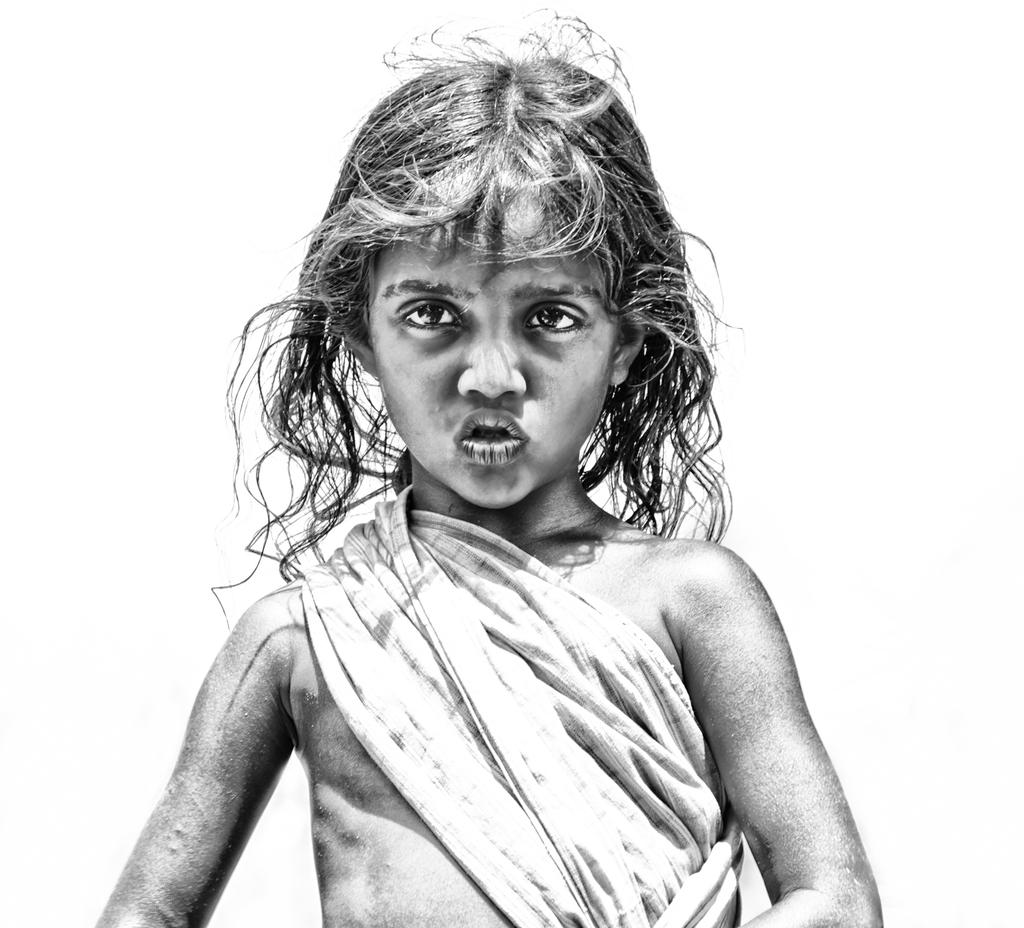What is the main subject of the painting in the image? The painting depicts a girl child. How is the girl child's hair represented in the painting? The girl child has scribbled hair in the painting. What is the girl child wearing in the painting? The girl child is wearing a cloth in the painting. How many bells can be seen hanging around the girl child in the painting? There are no bells present in the painting; it only depicts a girl child with scribbled hair and wearing a cloth. 